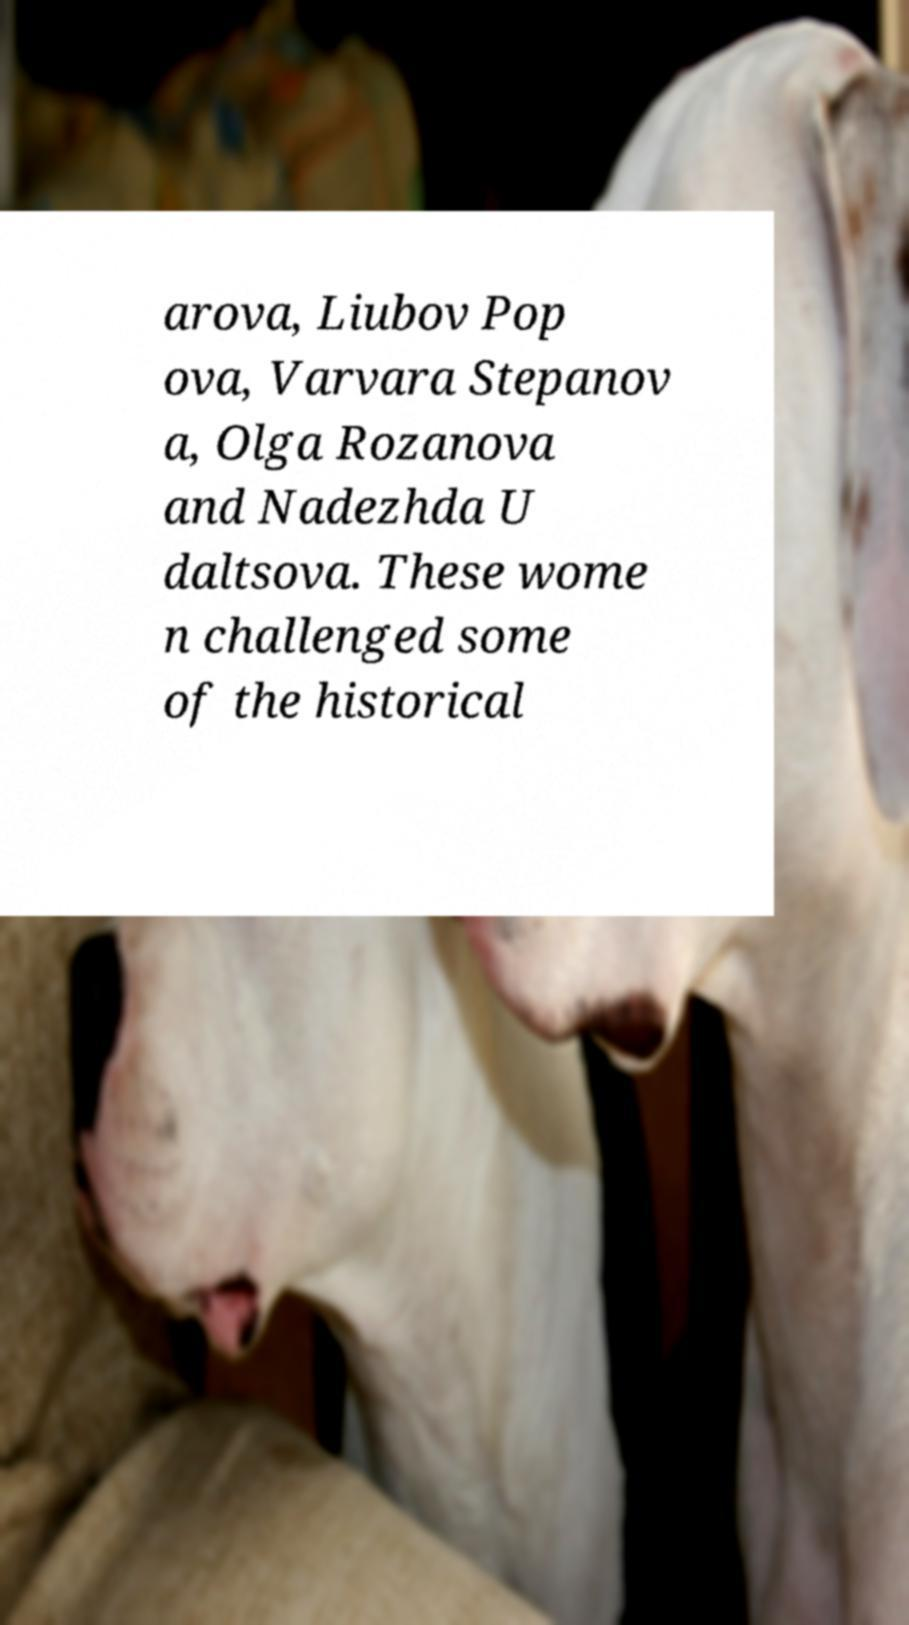There's text embedded in this image that I need extracted. Can you transcribe it verbatim? arova, Liubov Pop ova, Varvara Stepanov a, Olga Rozanova and Nadezhda U daltsova. These wome n challenged some of the historical 